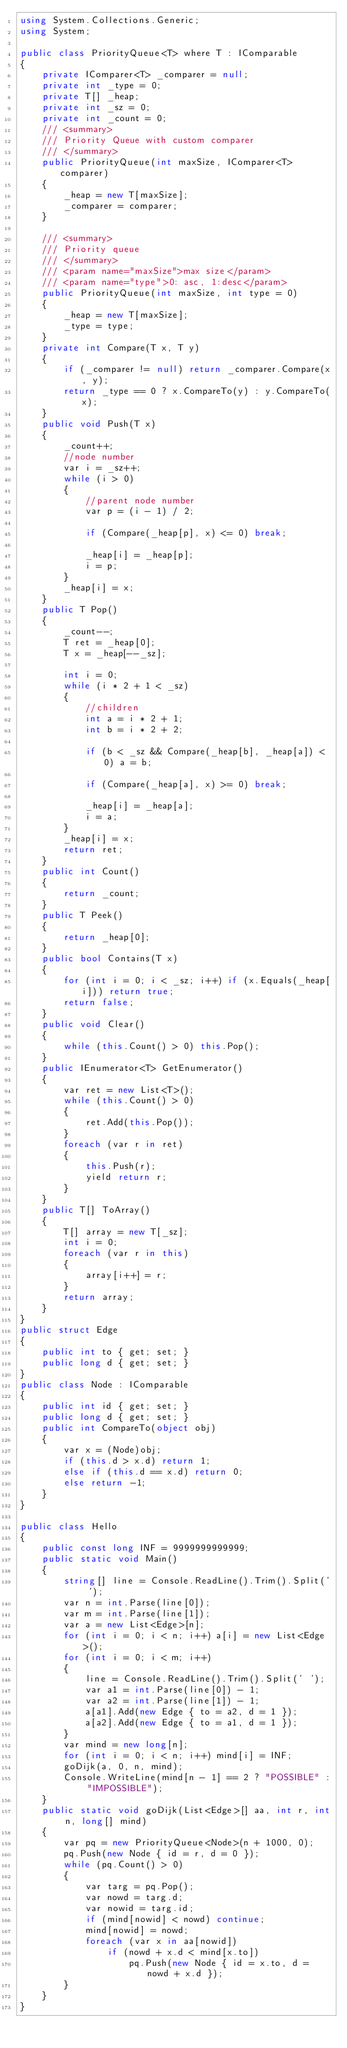Convert code to text. <code><loc_0><loc_0><loc_500><loc_500><_C#_>using System.Collections.Generic;
using System;

public class PriorityQueue<T> where T : IComparable
{
    private IComparer<T> _comparer = null;
    private int _type = 0;
    private T[] _heap;
    private int _sz = 0;
    private int _count = 0;
    /// <summary>
    /// Priority Queue with custom comparer
    /// </summary>
    public PriorityQueue(int maxSize, IComparer<T> comparer)
    {
        _heap = new T[maxSize];
        _comparer = comparer;
    }

    /// <summary>
    /// Priority queue
    /// </summary>
    /// <param name="maxSize">max size</param>
    /// <param name="type">0: asc, 1:desc</param>
    public PriorityQueue(int maxSize, int type = 0)
    {
        _heap = new T[maxSize];
        _type = type;
    }
    private int Compare(T x, T y)
    {
        if (_comparer != null) return _comparer.Compare(x, y);
        return _type == 0 ? x.CompareTo(y) : y.CompareTo(x);
    }
    public void Push(T x)
    {
        _count++;
        //node number
        var i = _sz++;
        while (i > 0)
        {
            //parent node number
            var p = (i - 1) / 2;

            if (Compare(_heap[p], x) <= 0) break;

            _heap[i] = _heap[p];
            i = p;
        }
        _heap[i] = x;
    }
    public T Pop()
    {
        _count--;
        T ret = _heap[0];
        T x = _heap[--_sz];

        int i = 0;
        while (i * 2 + 1 < _sz)
        {
            //children
            int a = i * 2 + 1;
            int b = i * 2 + 2;

            if (b < _sz && Compare(_heap[b], _heap[a]) < 0) a = b;

            if (Compare(_heap[a], x) >= 0) break;

            _heap[i] = _heap[a];
            i = a;
        }
        _heap[i] = x;
        return ret;
    }
    public int Count()
    {
        return _count;
    }
    public T Peek()
    {
        return _heap[0];
    }
    public bool Contains(T x)
    {
        for (int i = 0; i < _sz; i++) if (x.Equals(_heap[i])) return true;
        return false;
    }
    public void Clear()
    {
        while (this.Count() > 0) this.Pop();
    }
    public IEnumerator<T> GetEnumerator()
    {
        var ret = new List<T>();
        while (this.Count() > 0)
        {
            ret.Add(this.Pop());
        }
        foreach (var r in ret)
        {
            this.Push(r);
            yield return r;
        }
    }
    public T[] ToArray()
    {
        T[] array = new T[_sz];
        int i = 0;
        foreach (var r in this)
        {
            array[i++] = r;
        }
        return array;
    }
}
public struct Edge
{
    public int to { get; set; }
    public long d { get; set; }
}
public class Node : IComparable
{
    public int id { get; set; }
    public long d { get; set; }
    public int CompareTo(object obj)
    {
        var x = (Node)obj;
        if (this.d > x.d) return 1;
        else if (this.d == x.d) return 0;
        else return -1;
    }
}

public class Hello
{
    public const long INF = 9999999999999;
    public static void Main()
    {
        string[] line = Console.ReadLine().Trim().Split(' ');
        var n = int.Parse(line[0]);
        var m = int.Parse(line[1]);
        var a = new List<Edge>[n];
        for (int i = 0; i < n; i++) a[i] = new List<Edge>();
        for (int i = 0; i < m; i++)
        {
            line = Console.ReadLine().Trim().Split(' ');
            var a1 = int.Parse(line[0]) - 1;
            var a2 = int.Parse(line[1]) - 1;
            a[a1].Add(new Edge { to = a2, d = 1 });
            a[a2].Add(new Edge { to = a1, d = 1 });
        }
        var mind = new long[n];
        for (int i = 0; i < n; i++) mind[i] = INF;
        goDijk(a, 0, n, mind);
        Console.WriteLine(mind[n - 1] == 2 ? "POSSIBLE" : "IMPOSSIBLE");
    }
    public static void goDijk(List<Edge>[] aa, int r, int n, long[] mind)
    {
        var pq = new PriorityQueue<Node>(n + 1000, 0);
        pq.Push(new Node { id = r, d = 0 });
        while (pq.Count() > 0)
        {
            var targ = pq.Pop();
            var nowd = targ.d;
            var nowid = targ.id;
            if (mind[nowid] < nowd) continue;
            mind[nowid] = nowd;
            foreach (var x in aa[nowid])
                if (nowd + x.d < mind[x.to])
                    pq.Push(new Node { id = x.to, d = nowd + x.d });
        }
    }
}</code> 